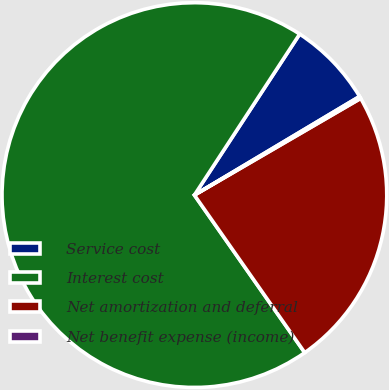<chart> <loc_0><loc_0><loc_500><loc_500><pie_chart><fcel>Service cost<fcel>Interest cost<fcel>Net amortization and deferral<fcel>Net benefit expense (income)<nl><fcel>7.22%<fcel>68.94%<fcel>23.66%<fcel>0.18%<nl></chart> 